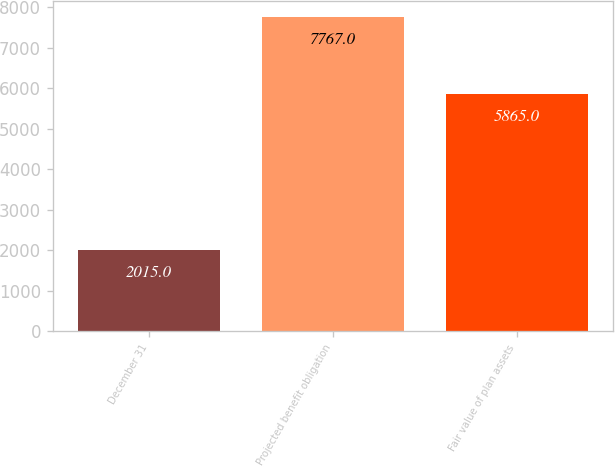Convert chart. <chart><loc_0><loc_0><loc_500><loc_500><bar_chart><fcel>December 31<fcel>Projected benefit obligation<fcel>Fair value of plan assets<nl><fcel>2015<fcel>7767<fcel>5865<nl></chart> 